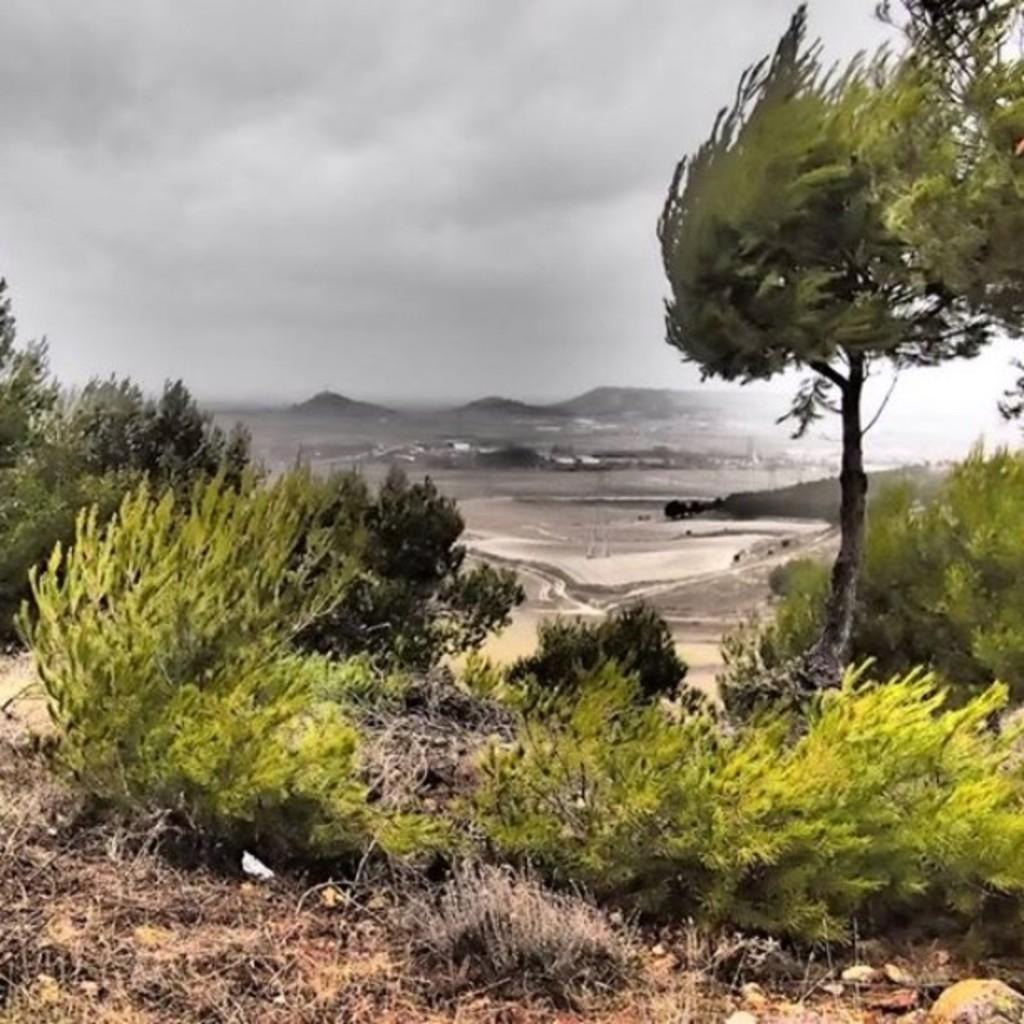What type of vegetation can be seen in the image? There are plants and trees in the image. What type of landscape feature is present in the image? There are hills in the image. What is the condition of the sky in the image? The sky is cloudy in the image. What type of bun is being held by the owner of the plants in the image? There is no person, bun, or indication of ownership in the image. 